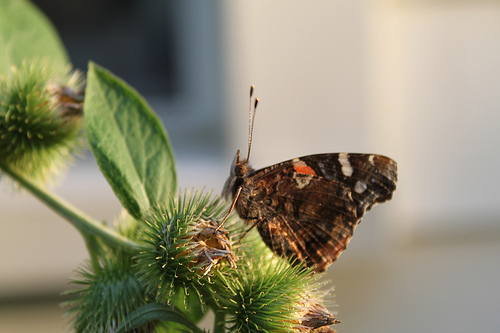<image>
Can you confirm if the butterfly is on the leaf? No. The butterfly is not positioned on the leaf. They may be near each other, but the butterfly is not supported by or resting on top of the leaf. 